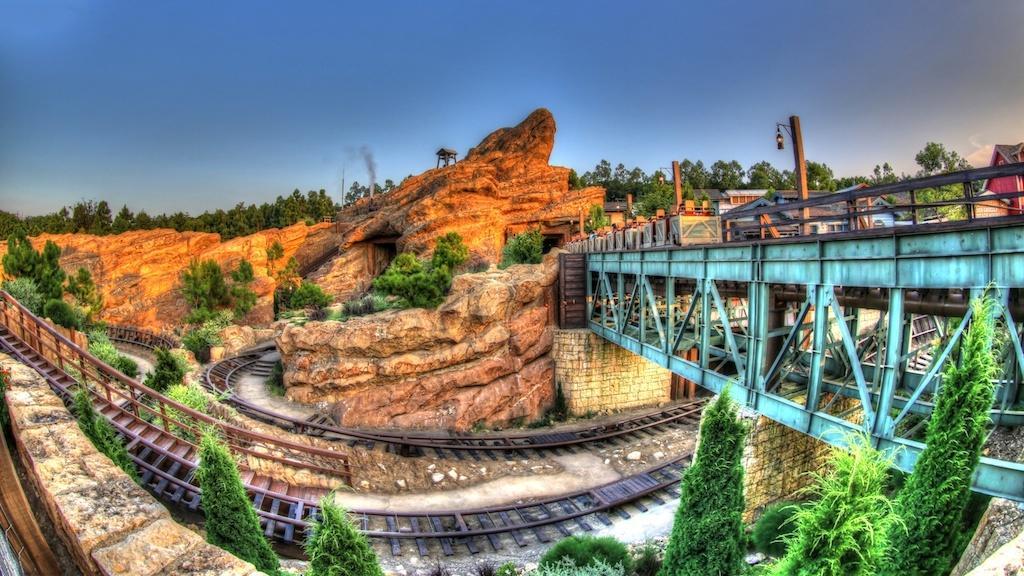Can you describe this image briefly? In this picture we can see a bridge, houses, wooden poles, trees, railway tracks, rocks, walls, smoke, hut and in the background we can see the sky. 